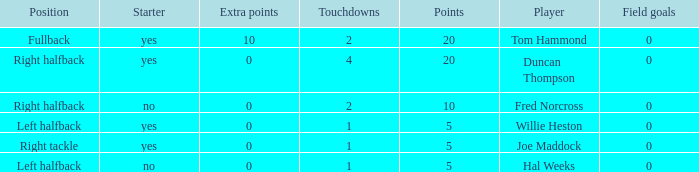How many touchdowns are there when there were 0 extra points and Hal Weeks had left halfback? 1.0. 